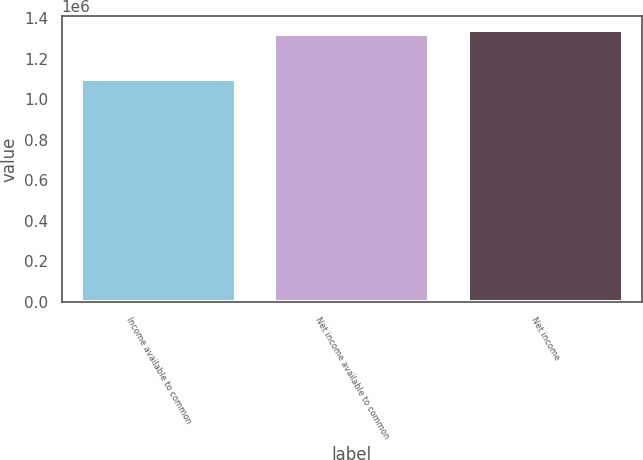Convert chart. <chart><loc_0><loc_0><loc_500><loc_500><bar_chart><fcel>Income available to common<fcel>Net income available to common<fcel>Net income<nl><fcel>1.09813e+06<fcel>1.32078e+06<fcel>1.34304e+06<nl></chart> 